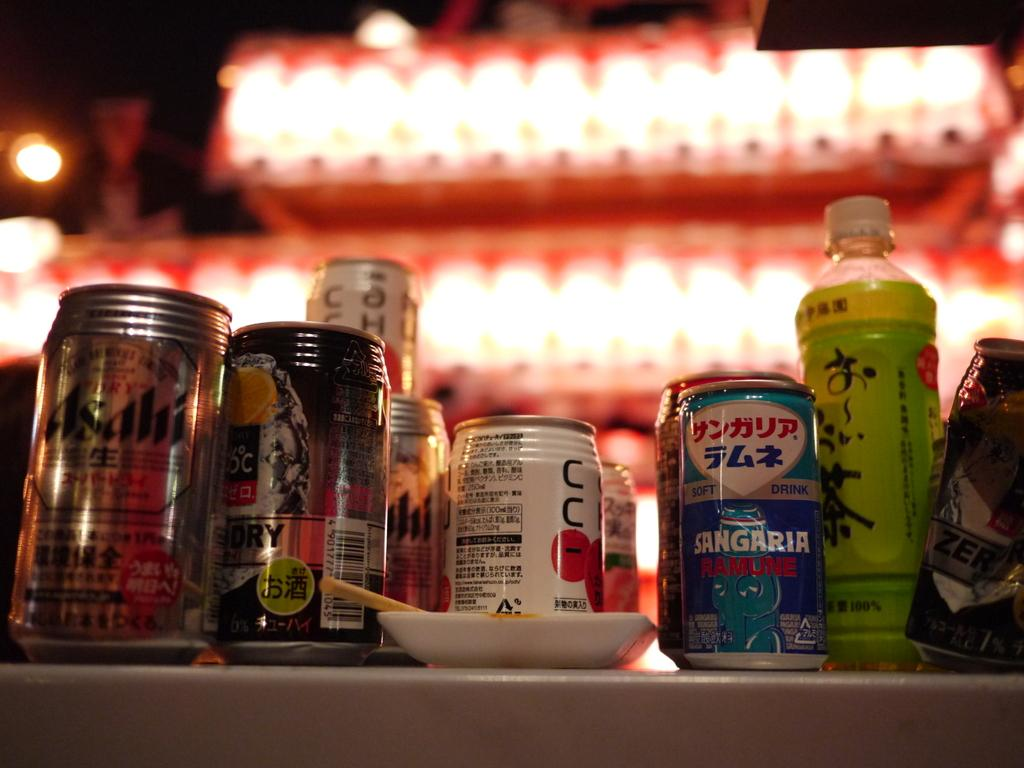What piece of furniture is present in the image? There is a table in the image. What items can be seen on the table? There are bottles, cans, and a plate on the table. What is unique about the cans on the table? The cans have stickers on them. Can you describe the lighting in the image? There is light in the background of the image. What type of toothpaste is being used to write on the collar of the quill in the image? There is no toothpaste, collar, or quill present in the image. 